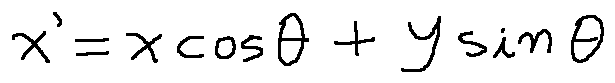<formula> <loc_0><loc_0><loc_500><loc_500>x ^ { \prime } = x \cos \theta + y \sin \theta</formula> 